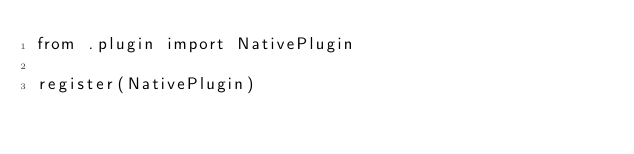<code> <loc_0><loc_0><loc_500><loc_500><_Python_>from .plugin import NativePlugin

register(NativePlugin)
</code> 